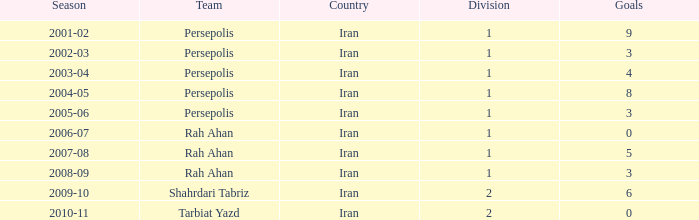What is the usual goals, when team is "rah ahan", and when division is lesser than 1? None. 